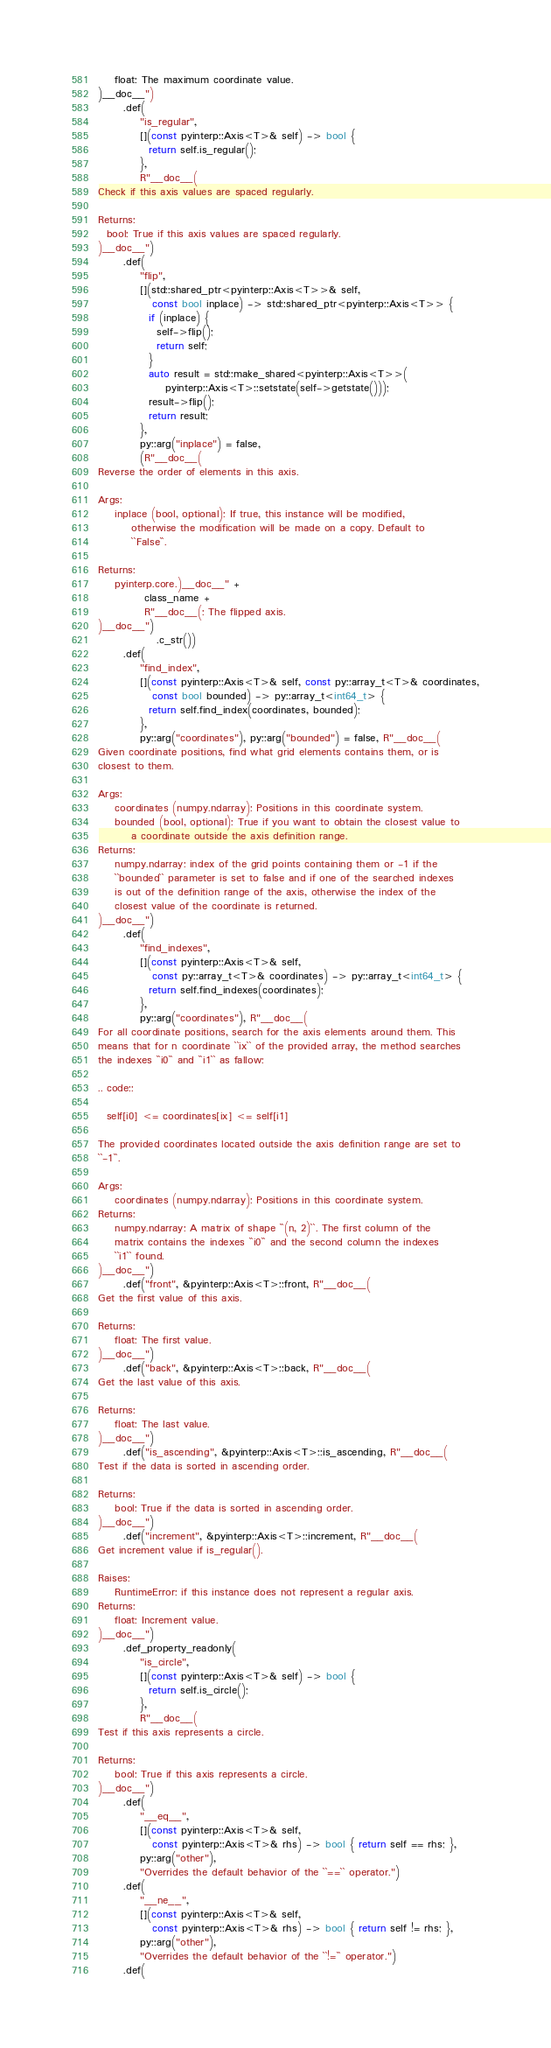<code> <loc_0><loc_0><loc_500><loc_500><_C++_>    float: The maximum coordinate value.
)__doc__")
      .def(
          "is_regular",
          [](const pyinterp::Axis<T>& self) -> bool {
            return self.is_regular();
          },
          R"__doc__(
Check if this axis values are spaced regularly.

Returns:
  bool: True if this axis values are spaced regularly.
)__doc__")
      .def(
          "flip",
          [](std::shared_ptr<pyinterp::Axis<T>>& self,
             const bool inplace) -> std::shared_ptr<pyinterp::Axis<T>> {
            if (inplace) {
              self->flip();
              return self;
            }
            auto result = std::make_shared<pyinterp::Axis<T>>(
                pyinterp::Axis<T>::setstate(self->getstate()));
            result->flip();
            return result;
          },
          py::arg("inplace") = false,
          (R"__doc__(
Reverse the order of elements in this axis.

Args:
    inplace (bool, optional): If true, this instance will be modified,
        otherwise the modification will be made on a copy. Default to
        ``False``.

Returns:
    pyinterp.core.)__doc__" +
           class_name +
           R"__doc__(: The flipped axis.
)__doc__")
              .c_str())
      .def(
          "find_index",
          [](const pyinterp::Axis<T>& self, const py::array_t<T>& coordinates,
             const bool bounded) -> py::array_t<int64_t> {
            return self.find_index(coordinates, bounded);
          },
          py::arg("coordinates"), py::arg("bounded") = false, R"__doc__(
Given coordinate positions, find what grid elements contains them, or is
closest to them.

Args:
    coordinates (numpy.ndarray): Positions in this coordinate system.
    bounded (bool, optional): True if you want to obtain the closest value to
        a coordinate outside the axis definition range.
Returns:
    numpy.ndarray: index of the grid points containing them or -1 if the
    ``bounded`` parameter is set to false and if one of the searched indexes
    is out of the definition range of the axis, otherwise the index of the
    closest value of the coordinate is returned.
)__doc__")
      .def(
          "find_indexes",
          [](const pyinterp::Axis<T>& self,
             const py::array_t<T>& coordinates) -> py::array_t<int64_t> {
            return self.find_indexes(coordinates);
          },
          py::arg("coordinates"), R"__doc__(
For all coordinate positions, search for the axis elements around them. This
means that for n coordinate ``ix`` of the provided array, the method searches
the indexes ``i0`` and ``i1`` as fallow:

.. code::

  self[i0] <= coordinates[ix] <= self[i1]

The provided coordinates located outside the axis definition range are set to
``-1``.

Args:
    coordinates (numpy.ndarray): Positions in this coordinate system.
Returns:
    numpy.ndarray: A matrix of shape ``(n, 2)``. The first column of the
    matrix contains the indexes ``i0`` and the second column the indexes
    ``i1`` found.
)__doc__")
      .def("front", &pyinterp::Axis<T>::front, R"__doc__(
Get the first value of this axis.

Returns:
    float: The first value.
)__doc__")
      .def("back", &pyinterp::Axis<T>::back, R"__doc__(
Get the last value of this axis.

Returns:
    float: The last value.
)__doc__")
      .def("is_ascending", &pyinterp::Axis<T>::is_ascending, R"__doc__(
Test if the data is sorted in ascending order.

Returns:
    bool: True if the data is sorted in ascending order.
)__doc__")
      .def("increment", &pyinterp::Axis<T>::increment, R"__doc__(
Get increment value if is_regular().

Raises:
    RuntimeError: if this instance does not represent a regular axis.
Returns:
    float: Increment value.
)__doc__")
      .def_property_readonly(
          "is_circle",
          [](const pyinterp::Axis<T>& self) -> bool {
            return self.is_circle();
          },
          R"__doc__(
Test if this axis represents a circle.

Returns:
    bool: True if this axis represents a circle.
)__doc__")
      .def(
          "__eq__",
          [](const pyinterp::Axis<T>& self,
             const pyinterp::Axis<T>& rhs) -> bool { return self == rhs; },
          py::arg("other"),
          "Overrides the default behavior of the ``==`` operator.")
      .def(
          "__ne__",
          [](const pyinterp::Axis<T>& self,
             const pyinterp::Axis<T>& rhs) -> bool { return self != rhs; },
          py::arg("other"),
          "Overrides the default behavior of the ``!=`` operator.")
      .def(</code> 